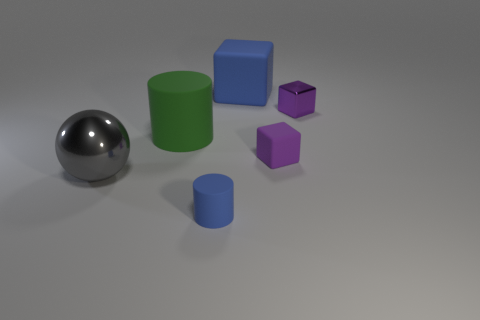Add 2 large yellow rubber blocks. How many objects exist? 8 Subtract all spheres. How many objects are left? 5 Add 1 small cyan matte cylinders. How many small cyan matte cylinders exist? 1 Subtract 1 blue cylinders. How many objects are left? 5 Subtract all large purple shiny objects. Subtract all small blue things. How many objects are left? 5 Add 1 large gray objects. How many large gray objects are left? 2 